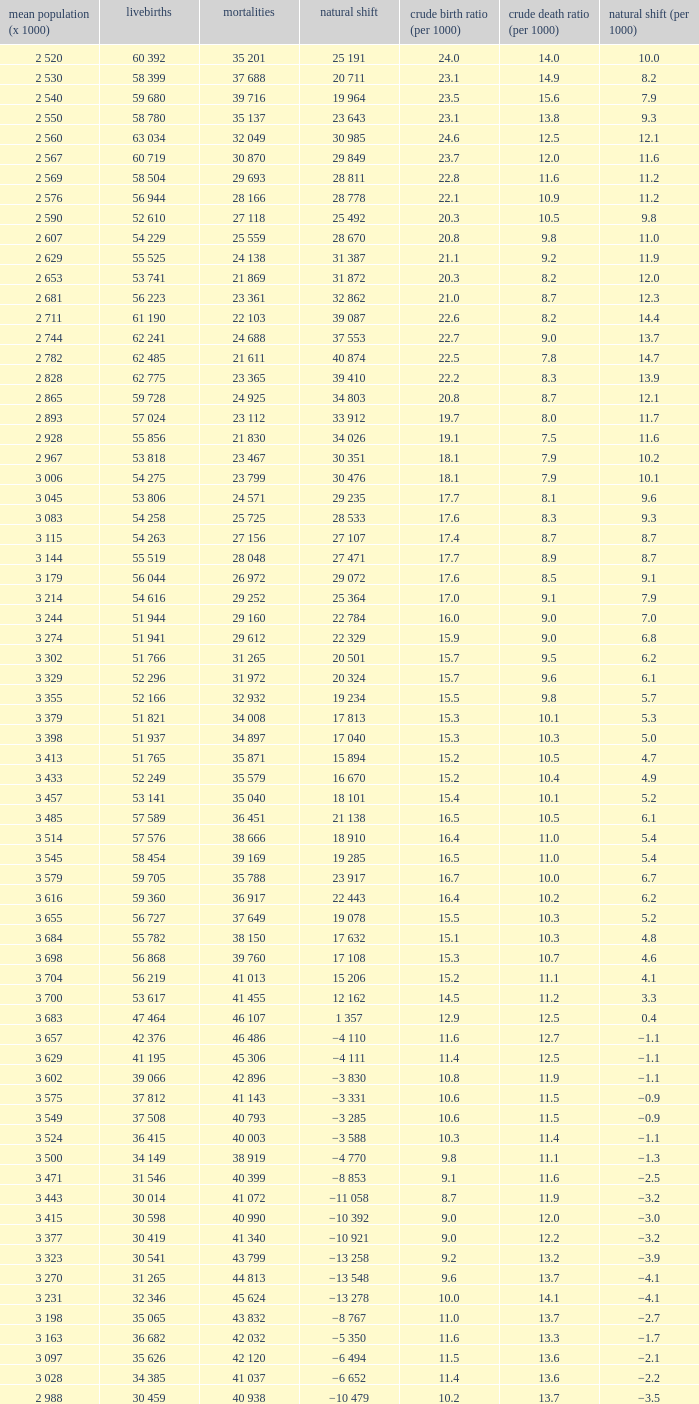Which Live births have a Natural change (per 1000) of 12.0? 53 741. 